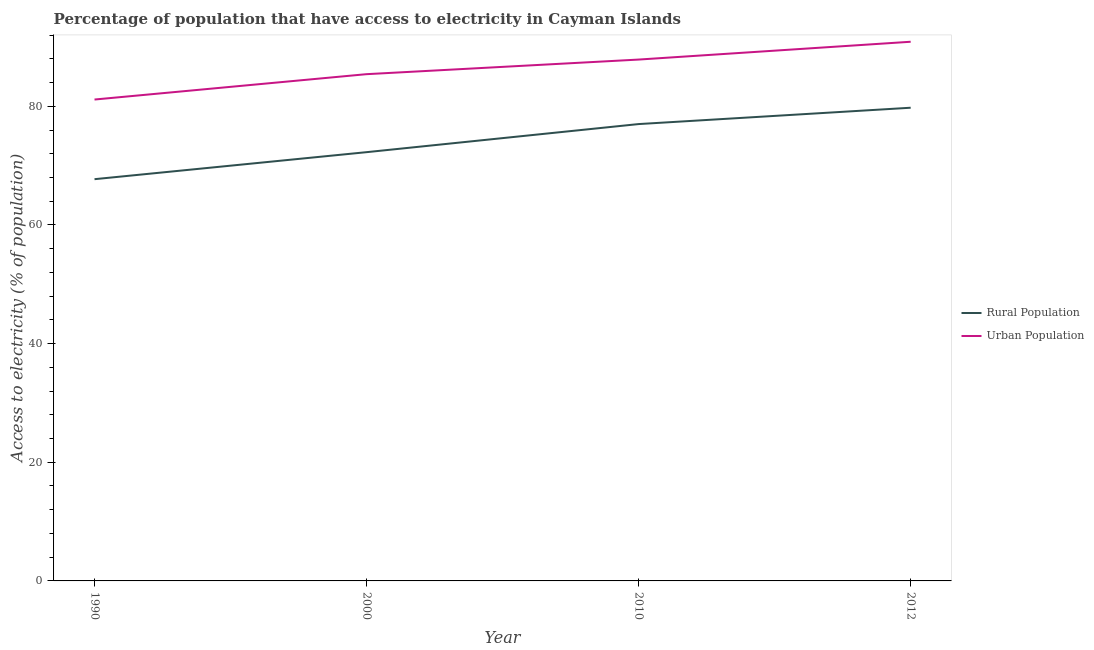Is the number of lines equal to the number of legend labels?
Provide a succinct answer. Yes. What is the percentage of urban population having access to electricity in 2012?
Your response must be concise. 90.88. Across all years, what is the maximum percentage of urban population having access to electricity?
Offer a terse response. 90.88. Across all years, what is the minimum percentage of rural population having access to electricity?
Keep it short and to the point. 67.71. In which year was the percentage of urban population having access to electricity minimum?
Provide a short and direct response. 1990. What is the total percentage of urban population having access to electricity in the graph?
Offer a very short reply. 345.3. What is the difference between the percentage of urban population having access to electricity in 2000 and that in 2010?
Keep it short and to the point. -2.46. What is the difference between the percentage of rural population having access to electricity in 2000 and the percentage of urban population having access to electricity in 2012?
Your response must be concise. -18.61. What is the average percentage of urban population having access to electricity per year?
Offer a terse response. 86.32. In the year 1990, what is the difference between the percentage of rural population having access to electricity and percentage of urban population having access to electricity?
Ensure brevity in your answer.  -13.42. What is the ratio of the percentage of rural population having access to electricity in 2000 to that in 2010?
Provide a succinct answer. 0.94. Is the percentage of urban population having access to electricity in 1990 less than that in 2012?
Keep it short and to the point. Yes. What is the difference between the highest and the second highest percentage of urban population having access to electricity?
Give a very brief answer. 3. What is the difference between the highest and the lowest percentage of rural population having access to electricity?
Offer a terse response. 12.04. Is the percentage of urban population having access to electricity strictly greater than the percentage of rural population having access to electricity over the years?
Give a very brief answer. Yes. Is the percentage of urban population having access to electricity strictly less than the percentage of rural population having access to electricity over the years?
Provide a succinct answer. No. How many years are there in the graph?
Provide a short and direct response. 4. Are the values on the major ticks of Y-axis written in scientific E-notation?
Provide a succinct answer. No. What is the title of the graph?
Provide a succinct answer. Percentage of population that have access to electricity in Cayman Islands. Does "Official creditors" appear as one of the legend labels in the graph?
Keep it short and to the point. No. What is the label or title of the Y-axis?
Give a very brief answer. Access to electricity (% of population). What is the Access to electricity (% of population) of Rural Population in 1990?
Give a very brief answer. 67.71. What is the Access to electricity (% of population) of Urban Population in 1990?
Your answer should be very brief. 81.14. What is the Access to electricity (% of population) in Rural Population in 2000?
Keep it short and to the point. 72.27. What is the Access to electricity (% of population) of Urban Population in 2000?
Offer a very short reply. 85.41. What is the Access to electricity (% of population) of Urban Population in 2010?
Offer a terse response. 87.87. What is the Access to electricity (% of population) in Rural Population in 2012?
Offer a very short reply. 79.75. What is the Access to electricity (% of population) of Urban Population in 2012?
Provide a succinct answer. 90.88. Across all years, what is the maximum Access to electricity (% of population) of Rural Population?
Give a very brief answer. 79.75. Across all years, what is the maximum Access to electricity (% of population) in Urban Population?
Offer a very short reply. 90.88. Across all years, what is the minimum Access to electricity (% of population) of Rural Population?
Provide a short and direct response. 67.71. Across all years, what is the minimum Access to electricity (% of population) of Urban Population?
Ensure brevity in your answer.  81.14. What is the total Access to electricity (% of population) of Rural Population in the graph?
Keep it short and to the point. 296.73. What is the total Access to electricity (% of population) of Urban Population in the graph?
Your answer should be compact. 345.3. What is the difference between the Access to electricity (% of population) of Rural Population in 1990 and that in 2000?
Your answer should be very brief. -4.55. What is the difference between the Access to electricity (% of population) of Urban Population in 1990 and that in 2000?
Give a very brief answer. -4.28. What is the difference between the Access to electricity (% of population) of Rural Population in 1990 and that in 2010?
Ensure brevity in your answer.  -9.29. What is the difference between the Access to electricity (% of population) of Urban Population in 1990 and that in 2010?
Ensure brevity in your answer.  -6.74. What is the difference between the Access to electricity (% of population) of Rural Population in 1990 and that in 2012?
Offer a terse response. -12.04. What is the difference between the Access to electricity (% of population) of Urban Population in 1990 and that in 2012?
Your response must be concise. -9.74. What is the difference between the Access to electricity (% of population) of Rural Population in 2000 and that in 2010?
Make the answer very short. -4.74. What is the difference between the Access to electricity (% of population) in Urban Population in 2000 and that in 2010?
Make the answer very short. -2.46. What is the difference between the Access to electricity (% of population) in Rural Population in 2000 and that in 2012?
Your response must be concise. -7.49. What is the difference between the Access to electricity (% of population) of Urban Population in 2000 and that in 2012?
Offer a terse response. -5.46. What is the difference between the Access to electricity (% of population) of Rural Population in 2010 and that in 2012?
Ensure brevity in your answer.  -2.75. What is the difference between the Access to electricity (% of population) of Urban Population in 2010 and that in 2012?
Provide a short and direct response. -3. What is the difference between the Access to electricity (% of population) of Rural Population in 1990 and the Access to electricity (% of population) of Urban Population in 2000?
Keep it short and to the point. -17.7. What is the difference between the Access to electricity (% of population) in Rural Population in 1990 and the Access to electricity (% of population) in Urban Population in 2010?
Your answer should be compact. -20.16. What is the difference between the Access to electricity (% of population) in Rural Population in 1990 and the Access to electricity (% of population) in Urban Population in 2012?
Ensure brevity in your answer.  -23.16. What is the difference between the Access to electricity (% of population) in Rural Population in 2000 and the Access to electricity (% of population) in Urban Population in 2010?
Make the answer very short. -15.61. What is the difference between the Access to electricity (% of population) of Rural Population in 2000 and the Access to electricity (% of population) of Urban Population in 2012?
Offer a terse response. -18.61. What is the difference between the Access to electricity (% of population) of Rural Population in 2010 and the Access to electricity (% of population) of Urban Population in 2012?
Make the answer very short. -13.88. What is the average Access to electricity (% of population) in Rural Population per year?
Your response must be concise. 74.18. What is the average Access to electricity (% of population) in Urban Population per year?
Ensure brevity in your answer.  86.32. In the year 1990, what is the difference between the Access to electricity (% of population) of Rural Population and Access to electricity (% of population) of Urban Population?
Offer a very short reply. -13.42. In the year 2000, what is the difference between the Access to electricity (% of population) of Rural Population and Access to electricity (% of population) of Urban Population?
Your answer should be compact. -13.15. In the year 2010, what is the difference between the Access to electricity (% of population) of Rural Population and Access to electricity (% of population) of Urban Population?
Provide a short and direct response. -10.87. In the year 2012, what is the difference between the Access to electricity (% of population) of Rural Population and Access to electricity (% of population) of Urban Population?
Your answer should be compact. -11.12. What is the ratio of the Access to electricity (% of population) of Rural Population in 1990 to that in 2000?
Your answer should be compact. 0.94. What is the ratio of the Access to electricity (% of population) of Urban Population in 1990 to that in 2000?
Provide a succinct answer. 0.95. What is the ratio of the Access to electricity (% of population) in Rural Population in 1990 to that in 2010?
Offer a very short reply. 0.88. What is the ratio of the Access to electricity (% of population) of Urban Population in 1990 to that in 2010?
Ensure brevity in your answer.  0.92. What is the ratio of the Access to electricity (% of population) of Rural Population in 1990 to that in 2012?
Ensure brevity in your answer.  0.85. What is the ratio of the Access to electricity (% of population) in Urban Population in 1990 to that in 2012?
Make the answer very short. 0.89. What is the ratio of the Access to electricity (% of population) of Rural Population in 2000 to that in 2010?
Provide a short and direct response. 0.94. What is the ratio of the Access to electricity (% of population) in Urban Population in 2000 to that in 2010?
Provide a succinct answer. 0.97. What is the ratio of the Access to electricity (% of population) of Rural Population in 2000 to that in 2012?
Provide a succinct answer. 0.91. What is the ratio of the Access to electricity (% of population) in Urban Population in 2000 to that in 2012?
Provide a succinct answer. 0.94. What is the ratio of the Access to electricity (% of population) in Rural Population in 2010 to that in 2012?
Offer a terse response. 0.97. What is the ratio of the Access to electricity (% of population) of Urban Population in 2010 to that in 2012?
Make the answer very short. 0.97. What is the difference between the highest and the second highest Access to electricity (% of population) of Rural Population?
Keep it short and to the point. 2.75. What is the difference between the highest and the second highest Access to electricity (% of population) in Urban Population?
Your answer should be compact. 3. What is the difference between the highest and the lowest Access to electricity (% of population) in Rural Population?
Keep it short and to the point. 12.04. What is the difference between the highest and the lowest Access to electricity (% of population) in Urban Population?
Your answer should be very brief. 9.74. 